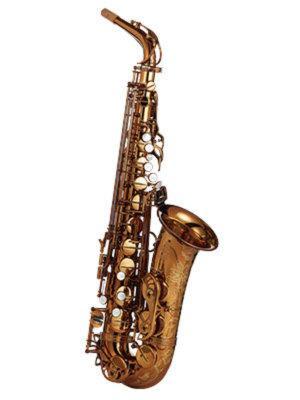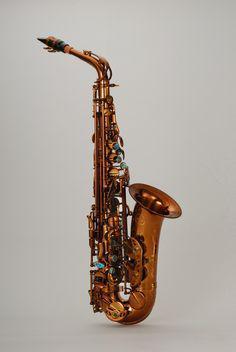The first image is the image on the left, the second image is the image on the right. Examine the images to the left and right. Is the description "The saxophone in one of the images is against a solid white background." accurate? Answer yes or no. Yes. 